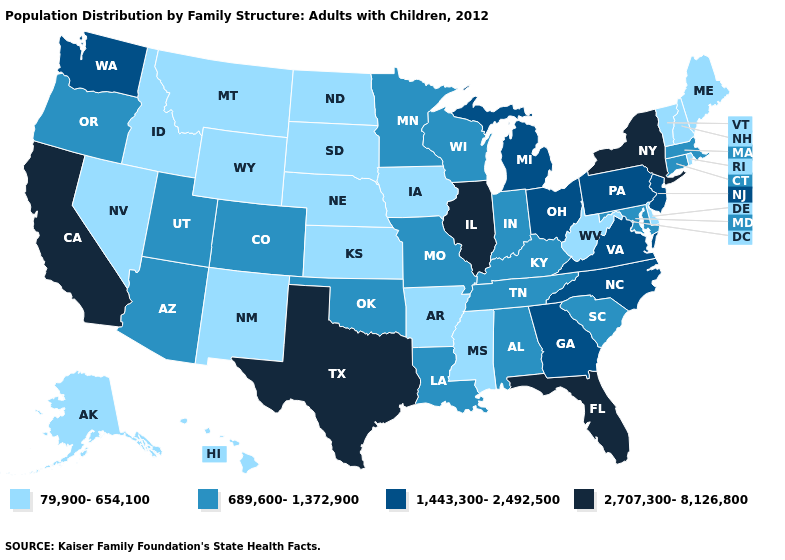Which states hav the highest value in the MidWest?
Write a very short answer. Illinois. Does Tennessee have the lowest value in the USA?
Give a very brief answer. No. Name the states that have a value in the range 2,707,300-8,126,800?
Concise answer only. California, Florida, Illinois, New York, Texas. How many symbols are there in the legend?
Answer briefly. 4. What is the lowest value in the South?
Quick response, please. 79,900-654,100. Among the states that border Rhode Island , which have the lowest value?
Keep it brief. Connecticut, Massachusetts. Does California have the highest value in the West?
Answer briefly. Yes. What is the value of Idaho?
Keep it brief. 79,900-654,100. Does the map have missing data?
Be succinct. No. Is the legend a continuous bar?
Quick response, please. No. Among the states that border New Mexico , which have the highest value?
Short answer required. Texas. What is the value of Pennsylvania?
Answer briefly. 1,443,300-2,492,500. What is the value of Nevada?
Concise answer only. 79,900-654,100. Name the states that have a value in the range 79,900-654,100?
Answer briefly. Alaska, Arkansas, Delaware, Hawaii, Idaho, Iowa, Kansas, Maine, Mississippi, Montana, Nebraska, Nevada, New Hampshire, New Mexico, North Dakota, Rhode Island, South Dakota, Vermont, West Virginia, Wyoming. What is the lowest value in the USA?
Give a very brief answer. 79,900-654,100. 